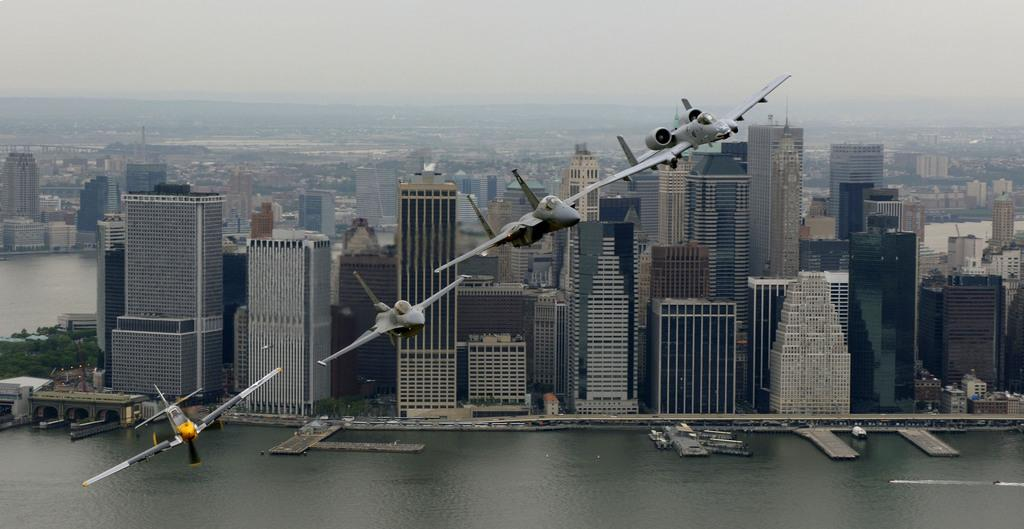What is the main subject of the image? The main subject of the image is airplanes. What else can be seen in the image besides airplanes? There are many buildings, trees, and water visible in the image. What is visible at the top of the image? The sky is visible at the top of the image. What type of quince is being used to repair the crack in the lawyer's briefcase in the image? There is no quince, crack, or lawyer's briefcase present in the image. 